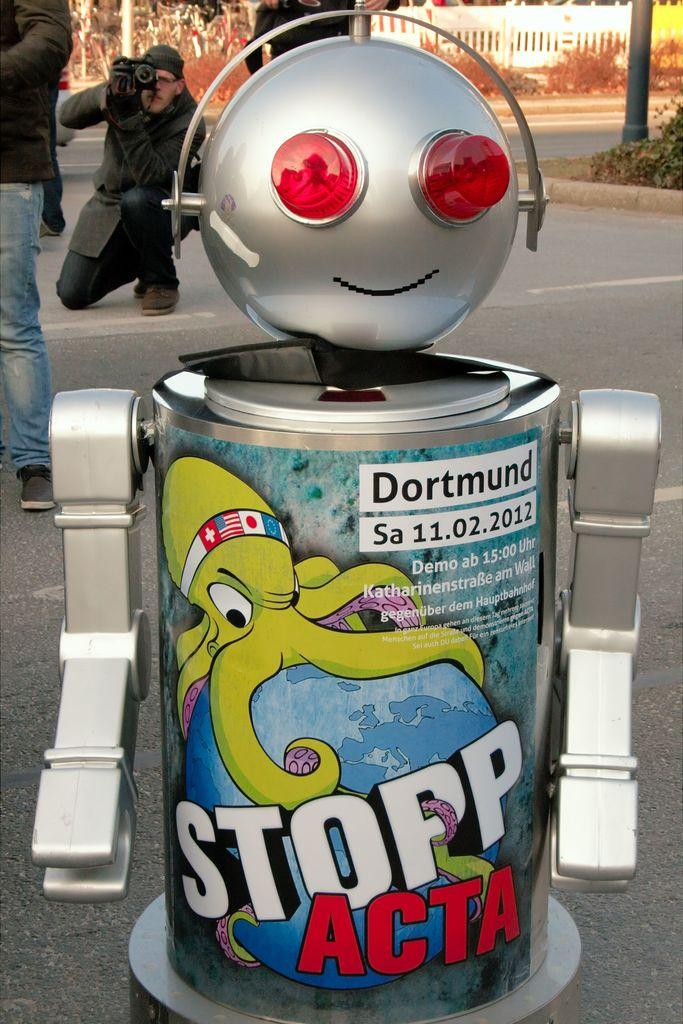What is the main subject of the image? The main subject of the image is a robot-shaped object. What is the man in the image doing? The man is taking a photograph in the image. Where is the man sitting while taking the photograph? The man is sitting on the road while taking the photograph. What hobbies does the robot have in the image? The image does not provide information about the robot's hobbies, as it is a static object and not a living being. 